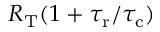<formula> <loc_0><loc_0><loc_500><loc_500>R _ { T } ( 1 + { \tau _ { r } } / { \tau _ { c } } )</formula> 